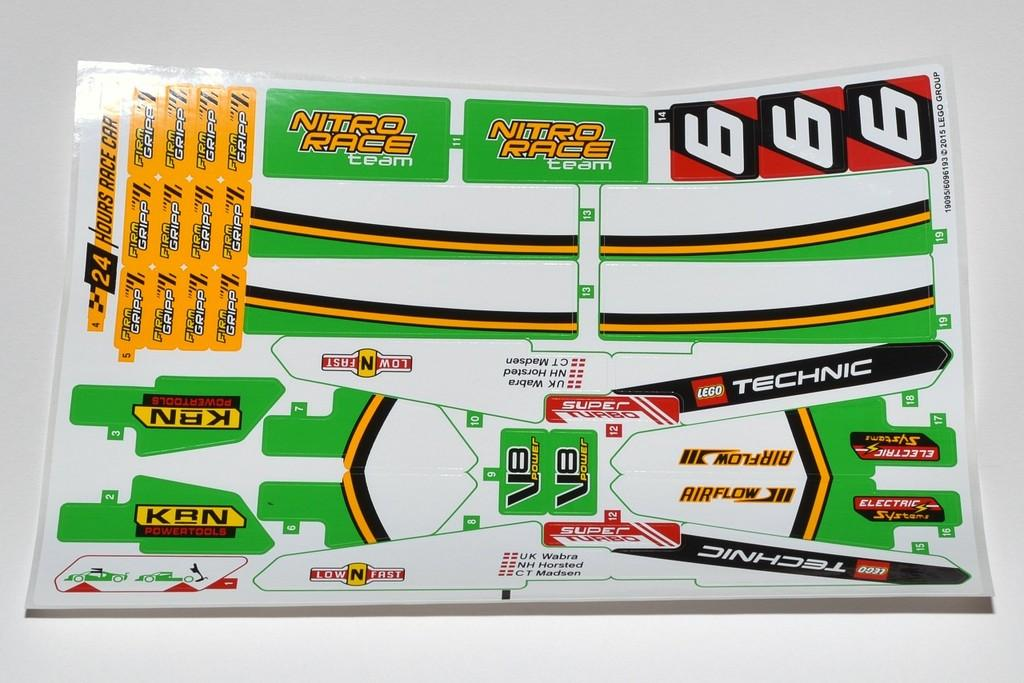<image>
Summarize the visual content of the image. A nitro race team set of stickers laying on a desk. 